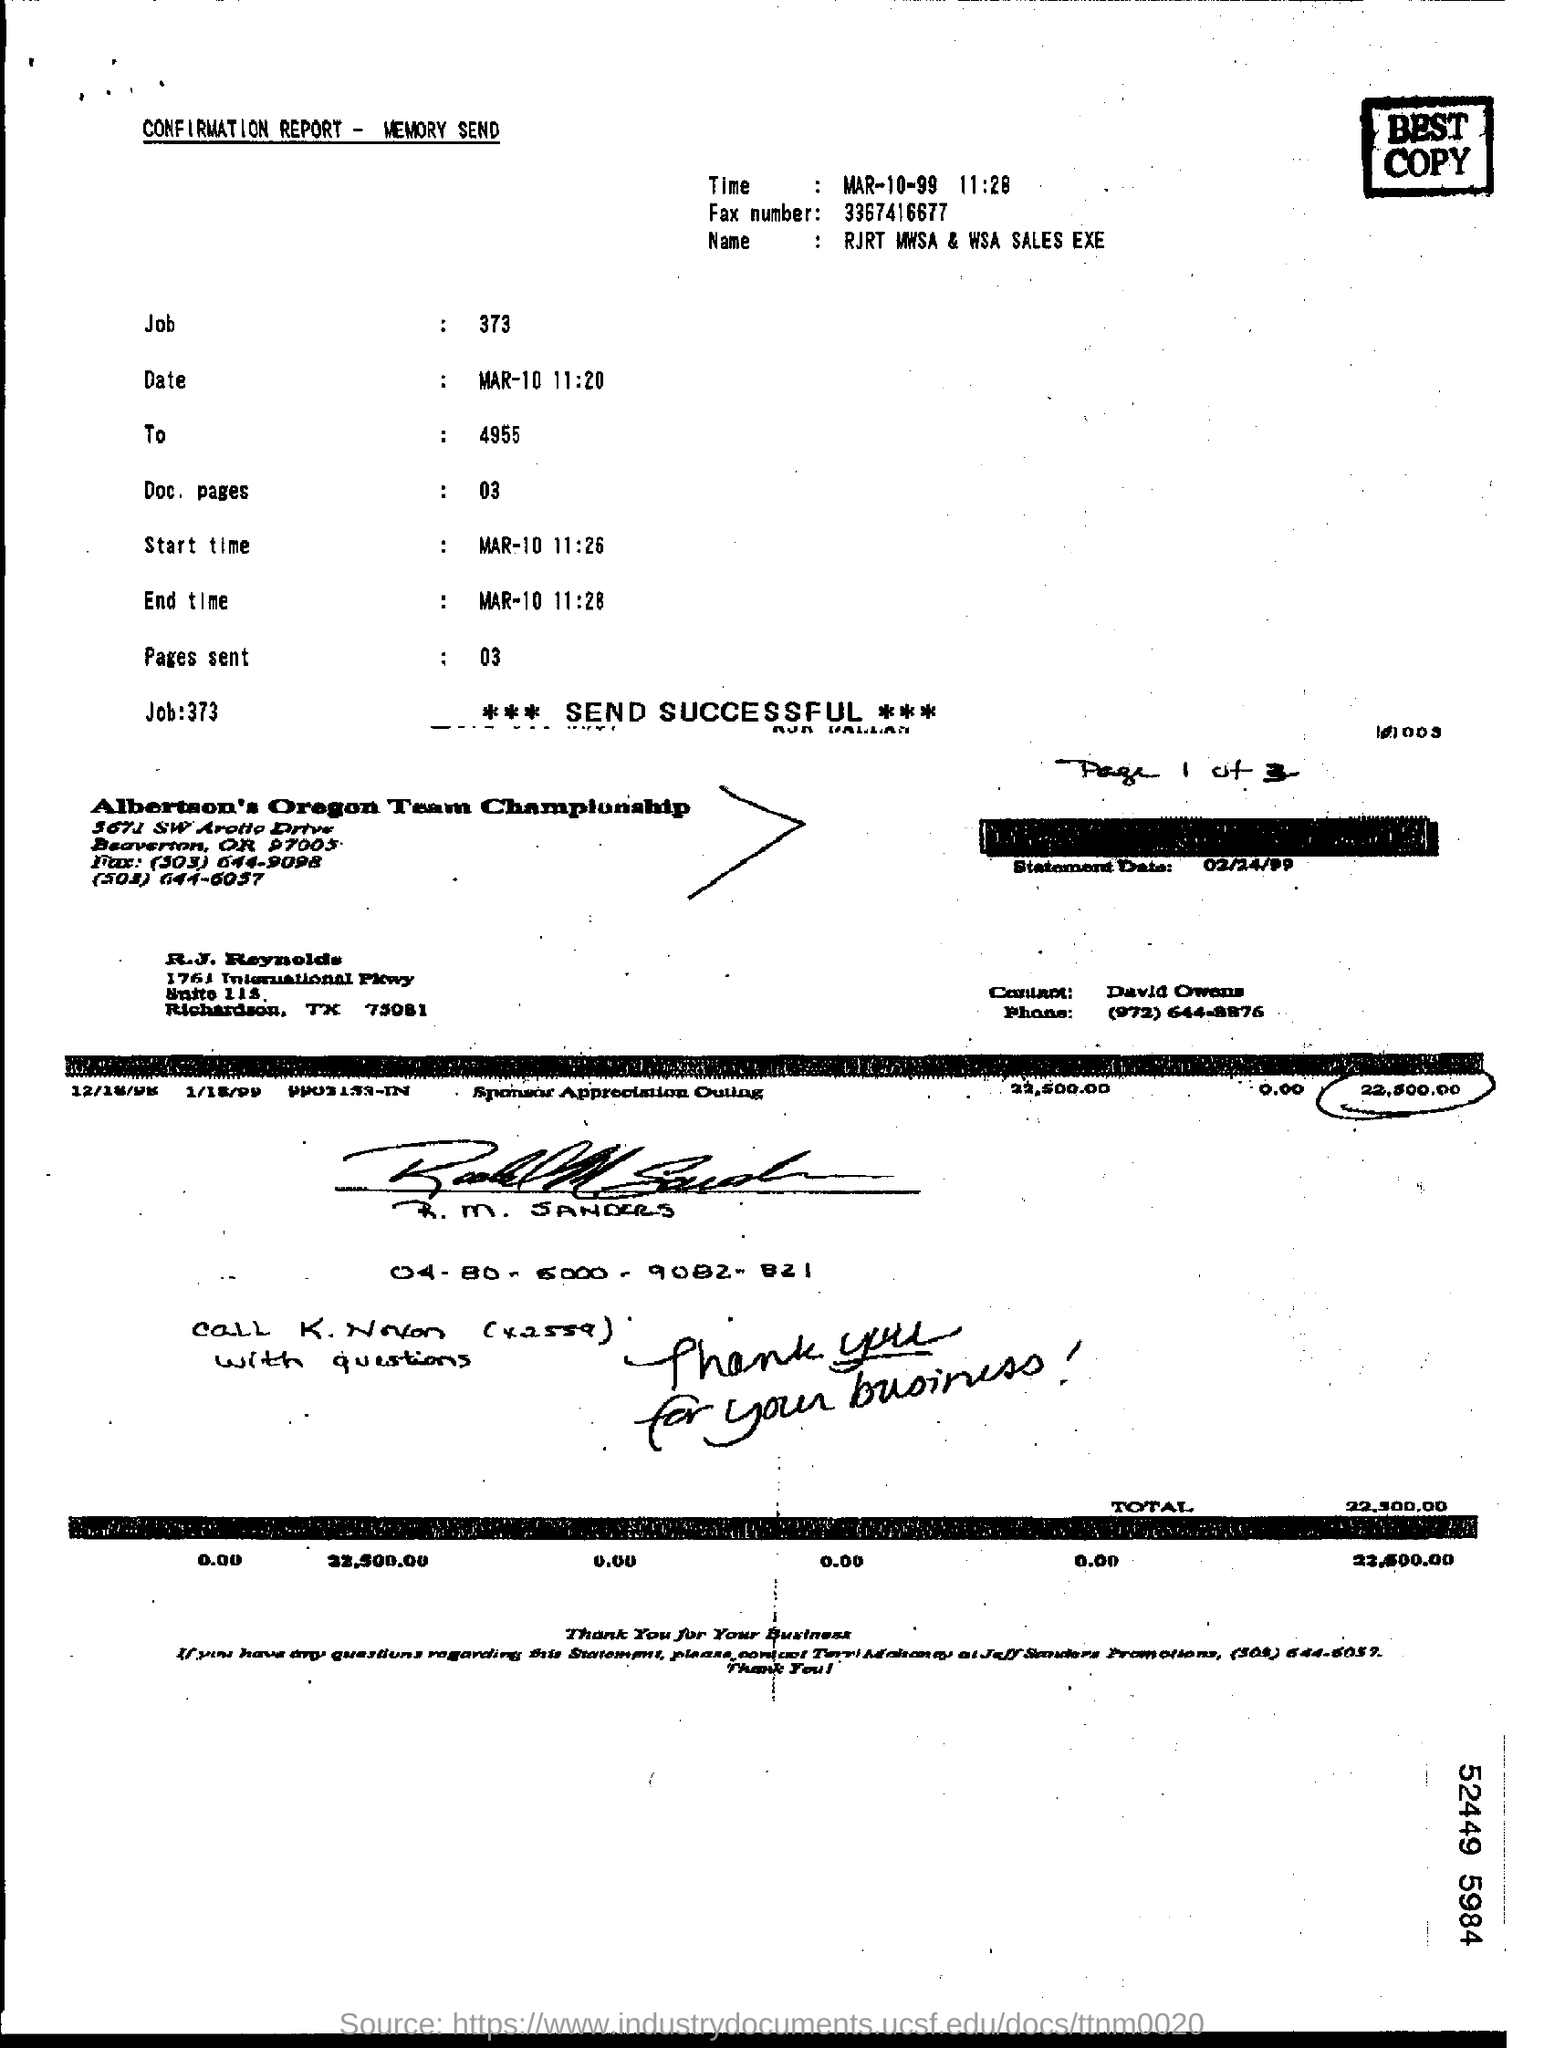What is the Fax number?
Offer a terse response. 3367416677. What is the name given in the form?
Your answer should be compact. RJRT MWSA & WSA SALES EXE. When is the start time?
Keep it short and to the point. MAR-10 11:26. 